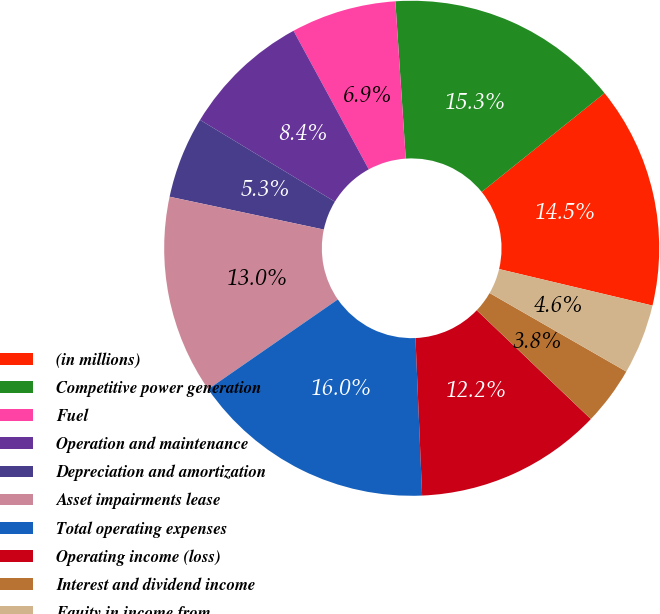Convert chart. <chart><loc_0><loc_0><loc_500><loc_500><pie_chart><fcel>(in millions)<fcel>Competitive power generation<fcel>Fuel<fcel>Operation and maintenance<fcel>Depreciation and amortization<fcel>Asset impairments lease<fcel>Total operating expenses<fcel>Operating income (loss)<fcel>Interest and dividend income<fcel>Equity in income from<nl><fcel>14.5%<fcel>15.27%<fcel>6.87%<fcel>8.4%<fcel>5.34%<fcel>12.98%<fcel>16.03%<fcel>12.21%<fcel>3.82%<fcel>4.58%<nl></chart> 